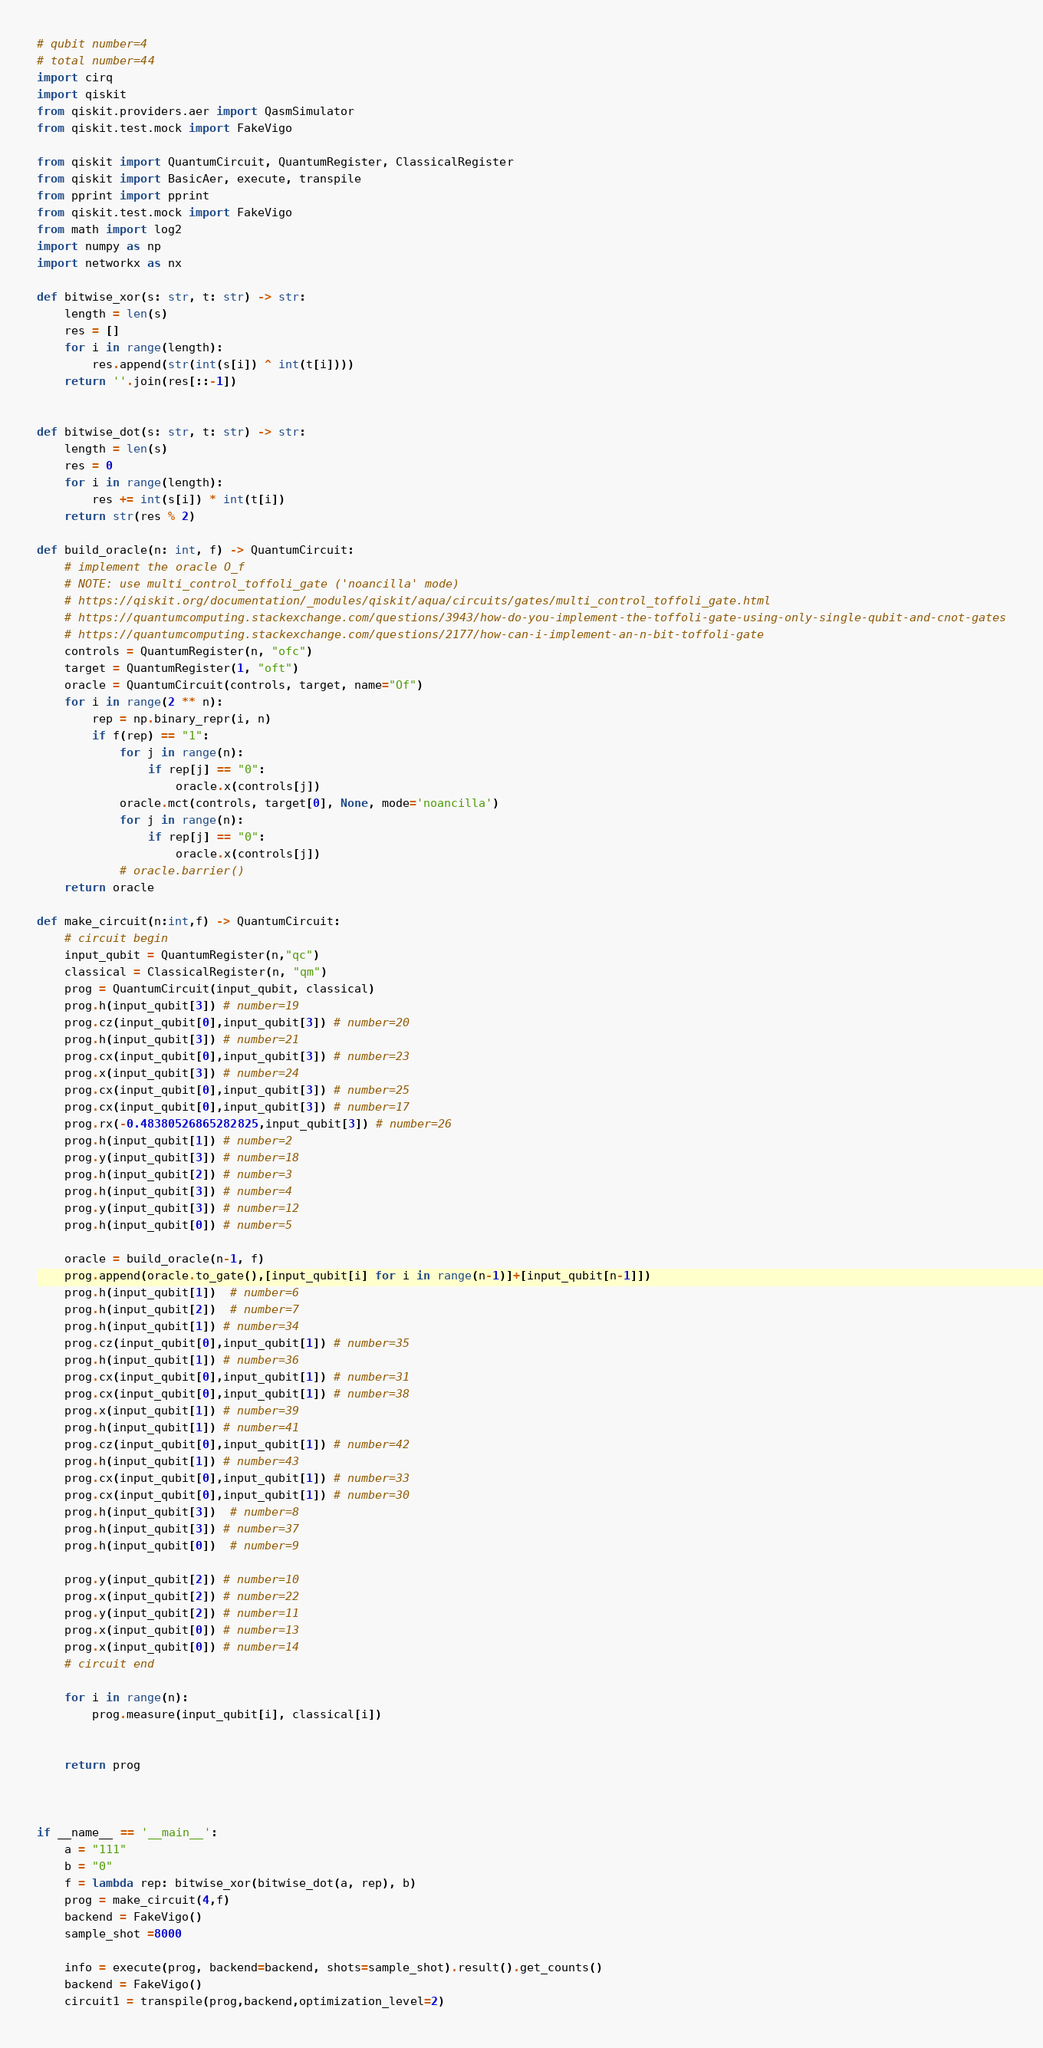<code> <loc_0><loc_0><loc_500><loc_500><_Python_># qubit number=4
# total number=44
import cirq
import qiskit
from qiskit.providers.aer import QasmSimulator
from qiskit.test.mock import FakeVigo

from qiskit import QuantumCircuit, QuantumRegister, ClassicalRegister
from qiskit import BasicAer, execute, transpile
from pprint import pprint
from qiskit.test.mock import FakeVigo
from math import log2
import numpy as np
import networkx as nx

def bitwise_xor(s: str, t: str) -> str:
    length = len(s)
    res = []
    for i in range(length):
        res.append(str(int(s[i]) ^ int(t[i])))
    return ''.join(res[::-1])


def bitwise_dot(s: str, t: str) -> str:
    length = len(s)
    res = 0
    for i in range(length):
        res += int(s[i]) * int(t[i])
    return str(res % 2)

def build_oracle(n: int, f) -> QuantumCircuit:
    # implement the oracle O_f
    # NOTE: use multi_control_toffoli_gate ('noancilla' mode)
    # https://qiskit.org/documentation/_modules/qiskit/aqua/circuits/gates/multi_control_toffoli_gate.html
    # https://quantumcomputing.stackexchange.com/questions/3943/how-do-you-implement-the-toffoli-gate-using-only-single-qubit-and-cnot-gates
    # https://quantumcomputing.stackexchange.com/questions/2177/how-can-i-implement-an-n-bit-toffoli-gate
    controls = QuantumRegister(n, "ofc")
    target = QuantumRegister(1, "oft")
    oracle = QuantumCircuit(controls, target, name="Of")
    for i in range(2 ** n):
        rep = np.binary_repr(i, n)
        if f(rep) == "1":
            for j in range(n):
                if rep[j] == "0":
                    oracle.x(controls[j])
            oracle.mct(controls, target[0], None, mode='noancilla')
            for j in range(n):
                if rep[j] == "0":
                    oracle.x(controls[j])
            # oracle.barrier()
    return oracle

def make_circuit(n:int,f) -> QuantumCircuit:
    # circuit begin
    input_qubit = QuantumRegister(n,"qc")
    classical = ClassicalRegister(n, "qm")
    prog = QuantumCircuit(input_qubit, classical)
    prog.h(input_qubit[3]) # number=19
    prog.cz(input_qubit[0],input_qubit[3]) # number=20
    prog.h(input_qubit[3]) # number=21
    prog.cx(input_qubit[0],input_qubit[3]) # number=23
    prog.x(input_qubit[3]) # number=24
    prog.cx(input_qubit[0],input_qubit[3]) # number=25
    prog.cx(input_qubit[0],input_qubit[3]) # number=17
    prog.rx(-0.48380526865282825,input_qubit[3]) # number=26
    prog.h(input_qubit[1]) # number=2
    prog.y(input_qubit[3]) # number=18
    prog.h(input_qubit[2]) # number=3
    prog.h(input_qubit[3]) # number=4
    prog.y(input_qubit[3]) # number=12
    prog.h(input_qubit[0]) # number=5

    oracle = build_oracle(n-1, f)
    prog.append(oracle.to_gate(),[input_qubit[i] for i in range(n-1)]+[input_qubit[n-1]])
    prog.h(input_qubit[1])  # number=6
    prog.h(input_qubit[2])  # number=7
    prog.h(input_qubit[1]) # number=34
    prog.cz(input_qubit[0],input_qubit[1]) # number=35
    prog.h(input_qubit[1]) # number=36
    prog.cx(input_qubit[0],input_qubit[1]) # number=31
    prog.cx(input_qubit[0],input_qubit[1]) # number=38
    prog.x(input_qubit[1]) # number=39
    prog.h(input_qubit[1]) # number=41
    prog.cz(input_qubit[0],input_qubit[1]) # number=42
    prog.h(input_qubit[1]) # number=43
    prog.cx(input_qubit[0],input_qubit[1]) # number=33
    prog.cx(input_qubit[0],input_qubit[1]) # number=30
    prog.h(input_qubit[3])  # number=8
    prog.h(input_qubit[3]) # number=37
    prog.h(input_qubit[0])  # number=9

    prog.y(input_qubit[2]) # number=10
    prog.x(input_qubit[2]) # number=22
    prog.y(input_qubit[2]) # number=11
    prog.x(input_qubit[0]) # number=13
    prog.x(input_qubit[0]) # number=14
    # circuit end

    for i in range(n):
        prog.measure(input_qubit[i], classical[i])


    return prog



if __name__ == '__main__':
    a = "111"
    b = "0"
    f = lambda rep: bitwise_xor(bitwise_dot(a, rep), b)
    prog = make_circuit(4,f)
    backend = FakeVigo()
    sample_shot =8000

    info = execute(prog, backend=backend, shots=sample_shot).result().get_counts()
    backend = FakeVigo()
    circuit1 = transpile(prog,backend,optimization_level=2)
</code> 